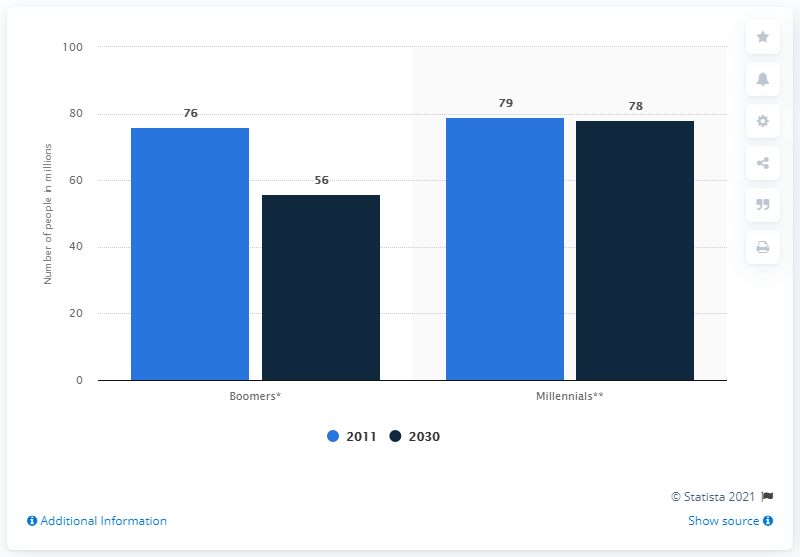Identify some key points in this picture. The Millennial generation is expected to have approximately 78 million people by 2030. By 2030, the number of people in the Boomer generation in the United States is projected to be approximately 56 million. 